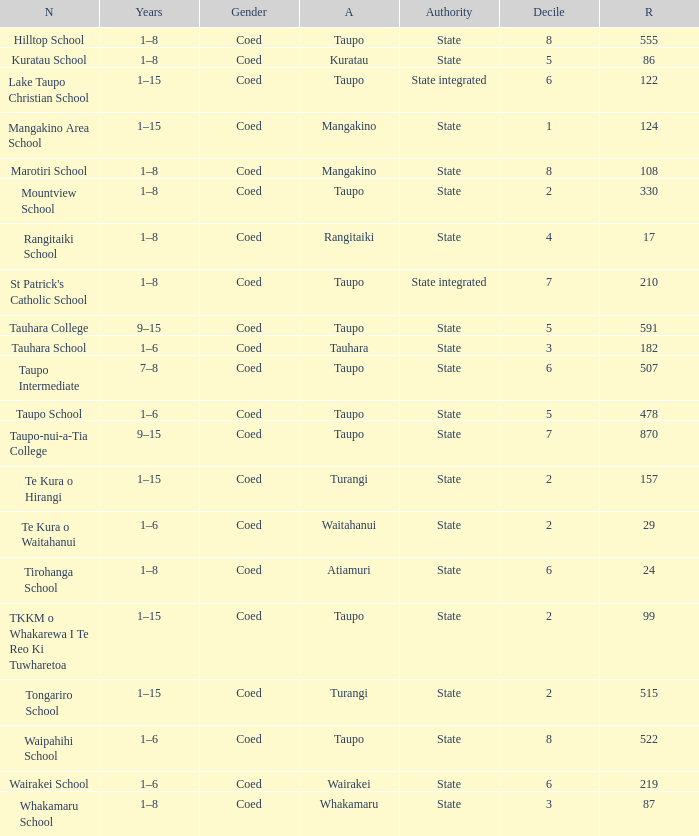What is the Whakamaru school's authority? State. 